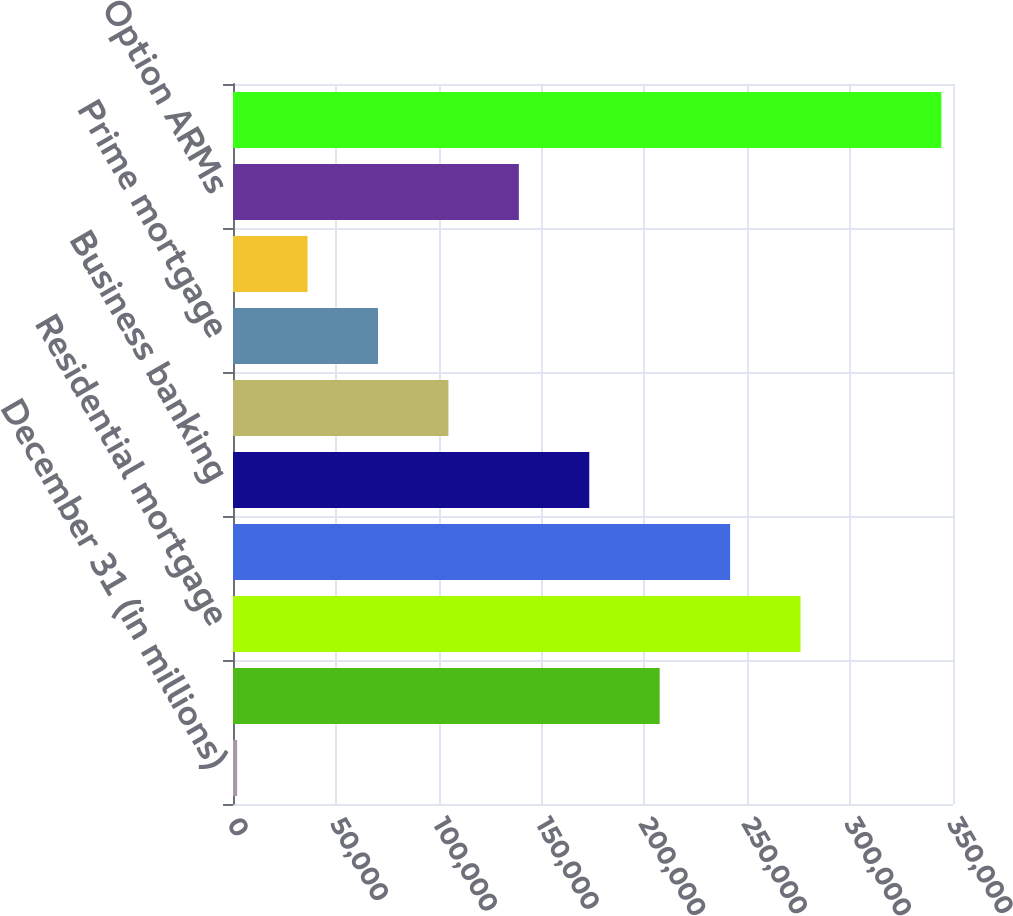Convert chart to OTSL. <chart><loc_0><loc_0><loc_500><loc_500><bar_chart><fcel>December 31 (in millions)<fcel>Home equity<fcel>Residential mortgage<fcel>Auto<fcel>Business banking<fcel>Student and other<fcel>Prime mortgage<fcel>Subprime mortgage<fcel>Option ARMs<fcel>Total retained loans<nl><fcel>2015<fcel>207419<fcel>275887<fcel>241653<fcel>173185<fcel>104717<fcel>70483<fcel>36249<fcel>138951<fcel>344355<nl></chart> 